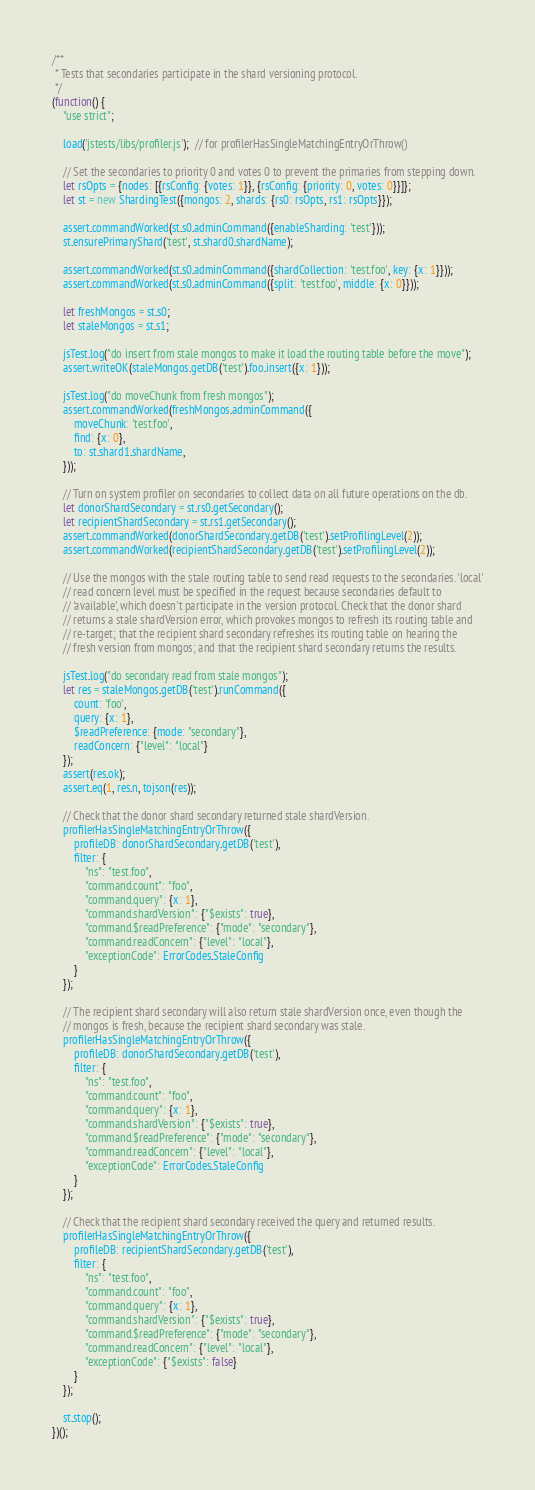<code> <loc_0><loc_0><loc_500><loc_500><_JavaScript_>/**
 * Tests that secondaries participate in the shard versioning protocol.
 */
(function() {
    "use strict";

    load('jstests/libs/profiler.js');  // for profilerHasSingleMatchingEntryOrThrow()

    // Set the secondaries to priority 0 and votes 0 to prevent the primaries from stepping down.
    let rsOpts = {nodes: [{rsConfig: {votes: 1}}, {rsConfig: {priority: 0, votes: 0}}]};
    let st = new ShardingTest({mongos: 2, shards: {rs0: rsOpts, rs1: rsOpts}});

    assert.commandWorked(st.s0.adminCommand({enableSharding: 'test'}));
    st.ensurePrimaryShard('test', st.shard0.shardName);

    assert.commandWorked(st.s0.adminCommand({shardCollection: 'test.foo', key: {x: 1}}));
    assert.commandWorked(st.s0.adminCommand({split: 'test.foo', middle: {x: 0}}));

    let freshMongos = st.s0;
    let staleMongos = st.s1;

    jsTest.log("do insert from stale mongos to make it load the routing table before the move");
    assert.writeOK(staleMongos.getDB('test').foo.insert({x: 1}));

    jsTest.log("do moveChunk from fresh mongos");
    assert.commandWorked(freshMongos.adminCommand({
        moveChunk: 'test.foo',
        find: {x: 0},
        to: st.shard1.shardName,
    }));

    // Turn on system profiler on secondaries to collect data on all future operations on the db.
    let donorShardSecondary = st.rs0.getSecondary();
    let recipientShardSecondary = st.rs1.getSecondary();
    assert.commandWorked(donorShardSecondary.getDB('test').setProfilingLevel(2));
    assert.commandWorked(recipientShardSecondary.getDB('test').setProfilingLevel(2));

    // Use the mongos with the stale routing table to send read requests to the secondaries. 'local'
    // read concern level must be specified in the request because secondaries default to
    // 'available', which doesn't participate in the version protocol. Check that the donor shard
    // returns a stale shardVersion error, which provokes mongos to refresh its routing table and
    // re-target; that the recipient shard secondary refreshes its routing table on hearing the
    // fresh version from mongos; and that the recipient shard secondary returns the results.

    jsTest.log("do secondary read from stale mongos");
    let res = staleMongos.getDB('test').runCommand({
        count: 'foo',
        query: {x: 1},
        $readPreference: {mode: "secondary"},
        readConcern: {"level": "local"}
    });
    assert(res.ok);
    assert.eq(1, res.n, tojson(res));

    // Check that the donor shard secondary returned stale shardVersion.
    profilerHasSingleMatchingEntryOrThrow({
        profileDB: donorShardSecondary.getDB('test'),
        filter: {
            "ns": "test.foo",
            "command.count": "foo",
            "command.query": {x: 1},
            "command.shardVersion": {"$exists": true},
            "command.$readPreference": {"mode": "secondary"},
            "command.readConcern": {"level": "local"},
            "exceptionCode": ErrorCodes.StaleConfig
        }
    });

    // The recipient shard secondary will also return stale shardVersion once, even though the
    // mongos is fresh, because the recipient shard secondary was stale.
    profilerHasSingleMatchingEntryOrThrow({
        profileDB: donorShardSecondary.getDB('test'),
        filter: {
            "ns": "test.foo",
            "command.count": "foo",
            "command.query": {x: 1},
            "command.shardVersion": {"$exists": true},
            "command.$readPreference": {"mode": "secondary"},
            "command.readConcern": {"level": "local"},
            "exceptionCode": ErrorCodes.StaleConfig
        }
    });

    // Check that the recipient shard secondary received the query and returned results.
    profilerHasSingleMatchingEntryOrThrow({
        profileDB: recipientShardSecondary.getDB('test'),
        filter: {
            "ns": "test.foo",
            "command.count": "foo",
            "command.query": {x: 1},
            "command.shardVersion": {"$exists": true},
            "command.$readPreference": {"mode": "secondary"},
            "command.readConcern": {"level": "local"},
            "exceptionCode": {"$exists": false}
        }
    });

    st.stop();
})();
</code> 